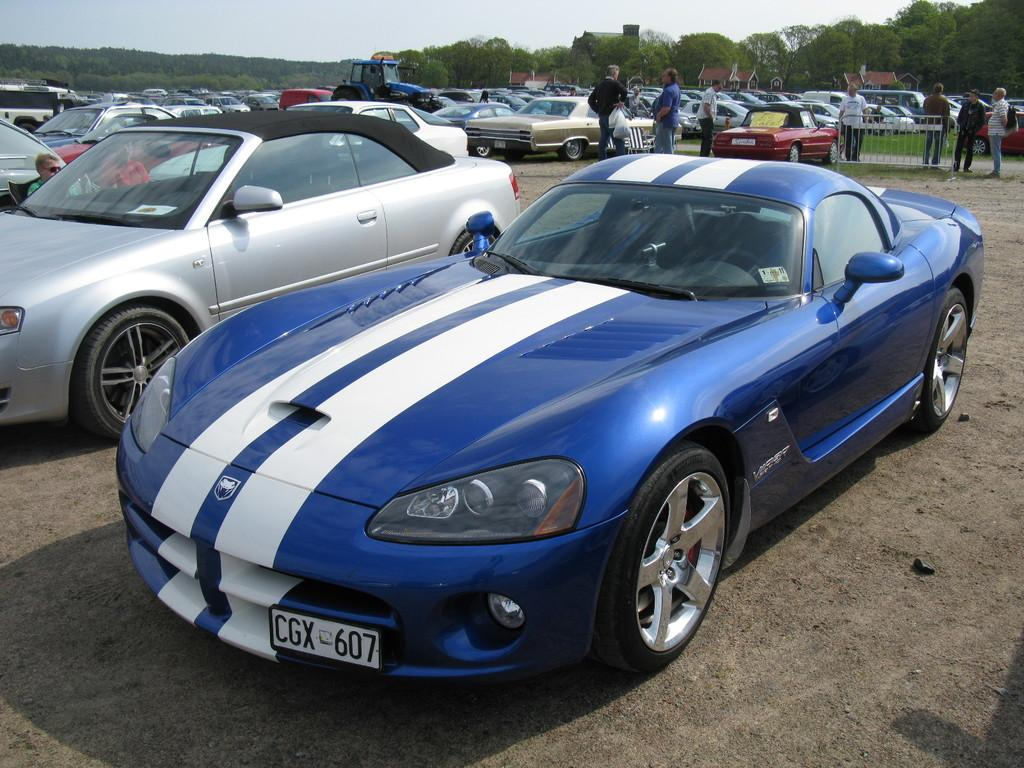What can be seen in the image? There is a group of vehicles and persons in the image. What might be separating the vehicles and persons in the image? There is a barrier in the image. What can be seen in the background of the image? There is a group of trees in the background of the image. What is visible at the top of the image? The sky is visible at the top of the image. What type of lipstick is the person wearing in the image? There is no indication of anyone wearing lipstick in the image. How many rings can be seen on the fingers of the persons in the image? There is no mention of rings on the fingers of the persons in the image. 